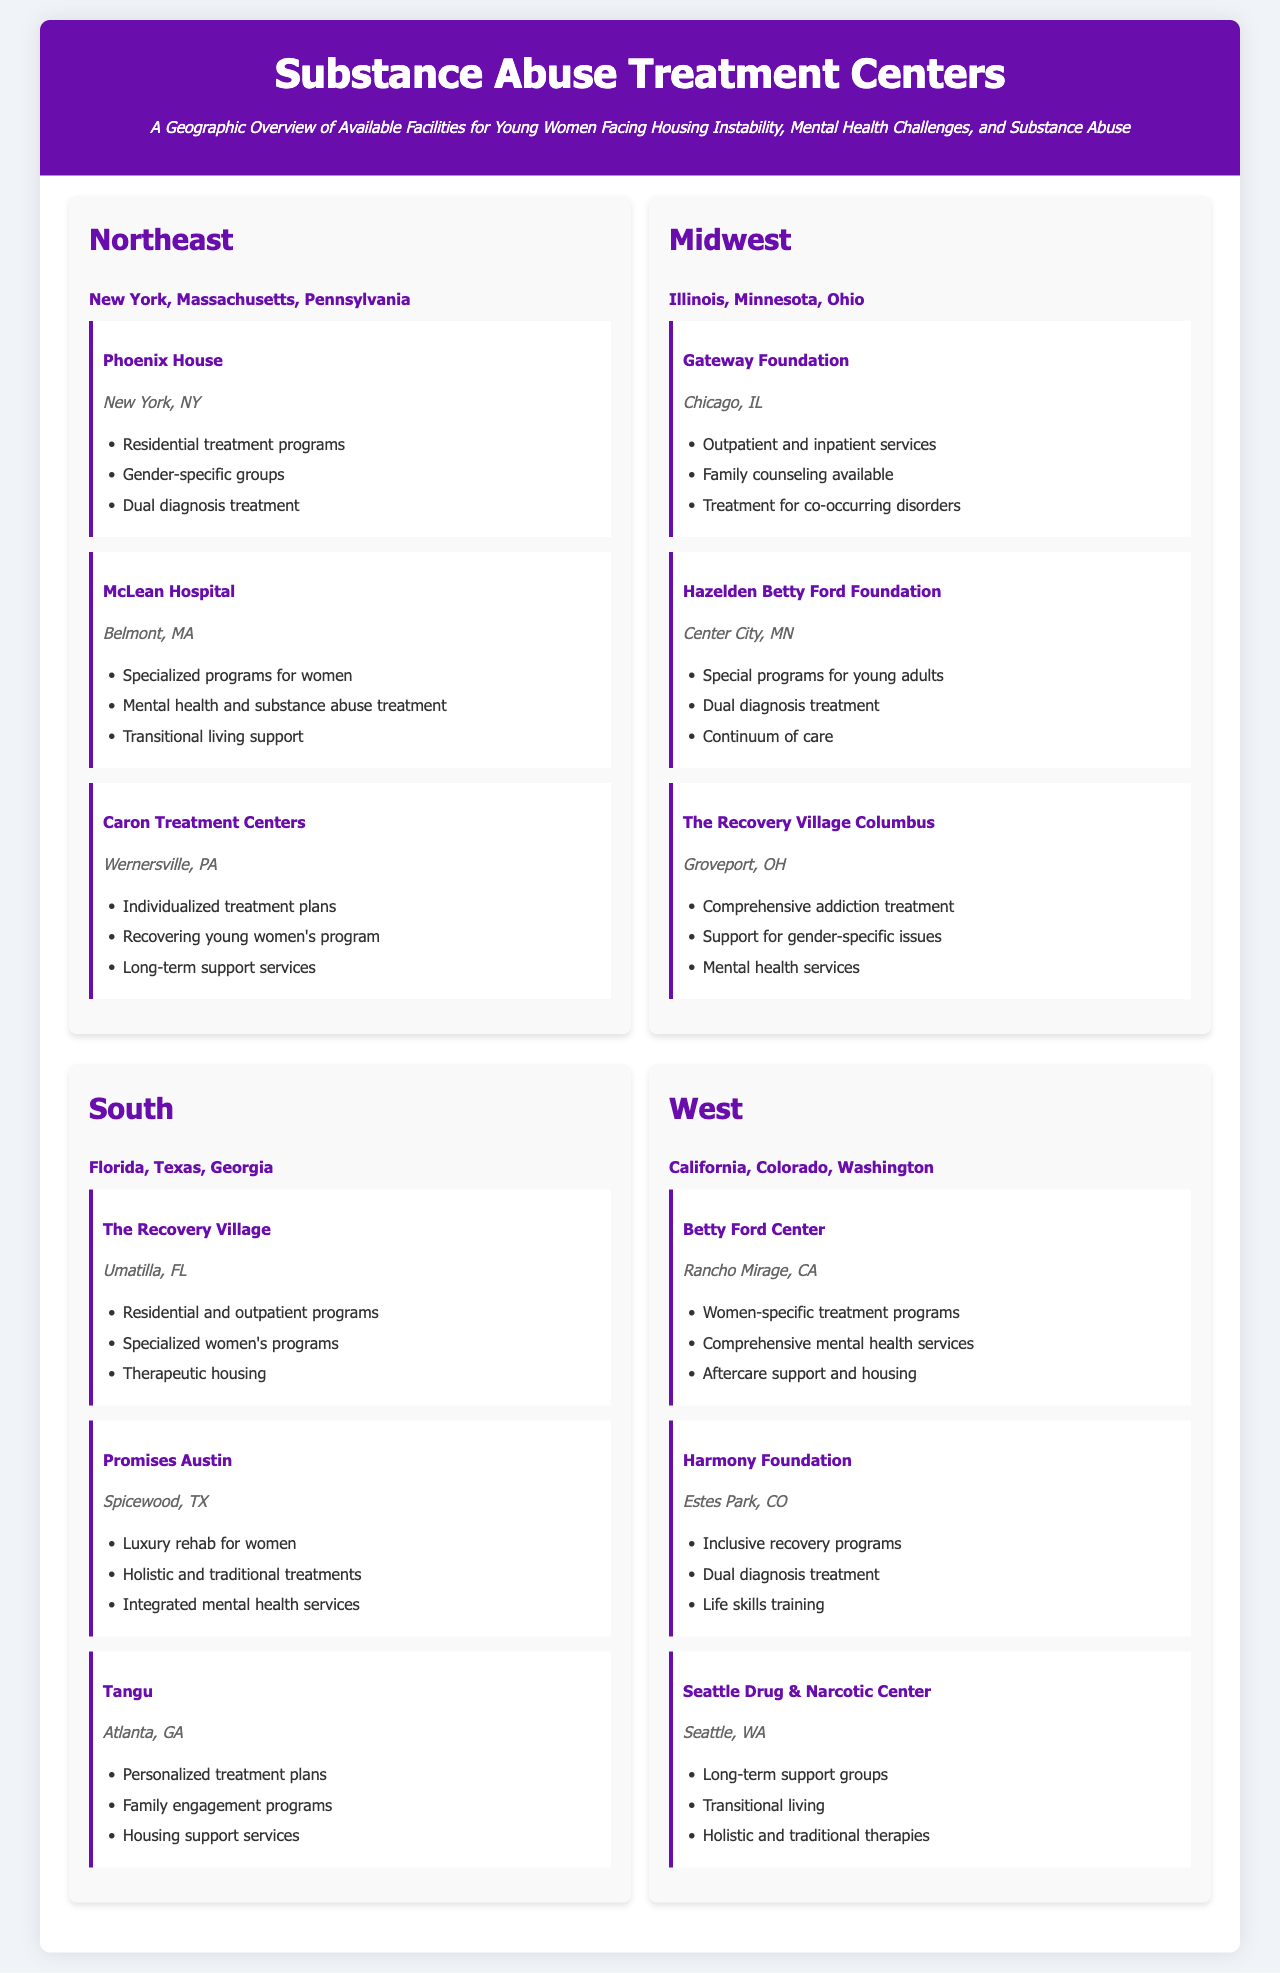what region includes New York? The Northeast region contains New York, along with Massachusetts and Pennsylvania as listed in the document.
Answer: Northeast how many facilities are listed in the South region? The South region includes three facilities as mentioned in the document.
Answer: 3 which facility offers transitional living support? McLean Hospital in Belmont, MA, offers transitional living support as a part of its services.
Answer: McLean Hospital what type of services does The Recovery Village offer? The Recovery Village in Umatilla, FL, offers residential and outpatient programs and specialized women's programs as indicated in the document.
Answer: Residential and outpatient programs which state is home to the Betty Ford Center? The Betty Ford Center is located in California, according to the document.
Answer: California what is the focus of the Tangu facility? Tangu in Atlanta, GA, focuses on personalized treatment plans and family engagement programs.
Answer: Personalized treatment plans how many states are included in the Midwest region? The Midwest region features three states: Illinois, Minnesota, and Ohio, as detailed in the document.
Answer: 3 which facility provides support for gender-specific issues? The Recovery Village Columbus in Groveport, OH, provides support for gender-specific issues as mentioned in the document.
Answer: The Recovery Village Columbus what kind of treatment does the Harmony Foundation specialize in? The Harmony Foundation specializes in inclusive recovery programs and dual diagnosis treatment as outlined in the document.
Answer: Inclusive recovery programs 